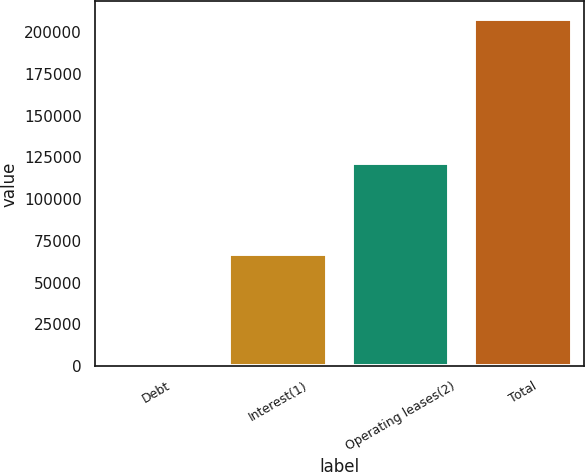Convert chart to OTSL. <chart><loc_0><loc_0><loc_500><loc_500><bar_chart><fcel>Debt<fcel>Interest(1)<fcel>Operating leases(2)<fcel>Total<nl><fcel>1080<fcel>66900<fcel>121622<fcel>207948<nl></chart> 